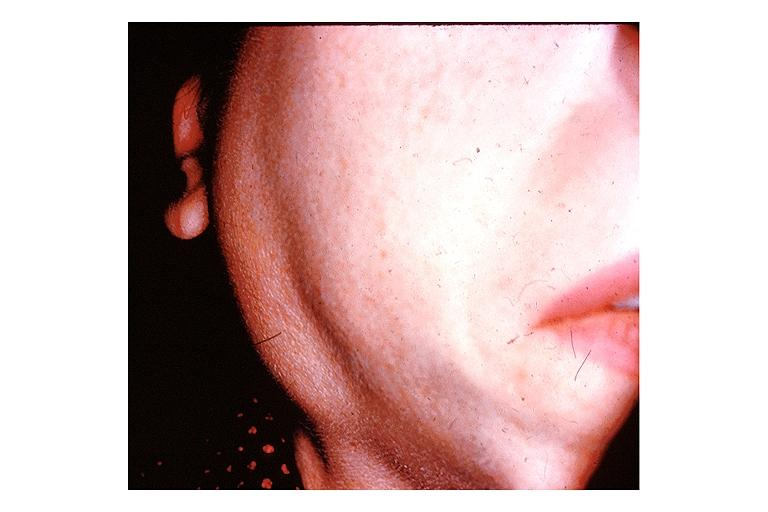does this image show sjogrens syndrome?
Answer the question using a single word or phrase. Yes 